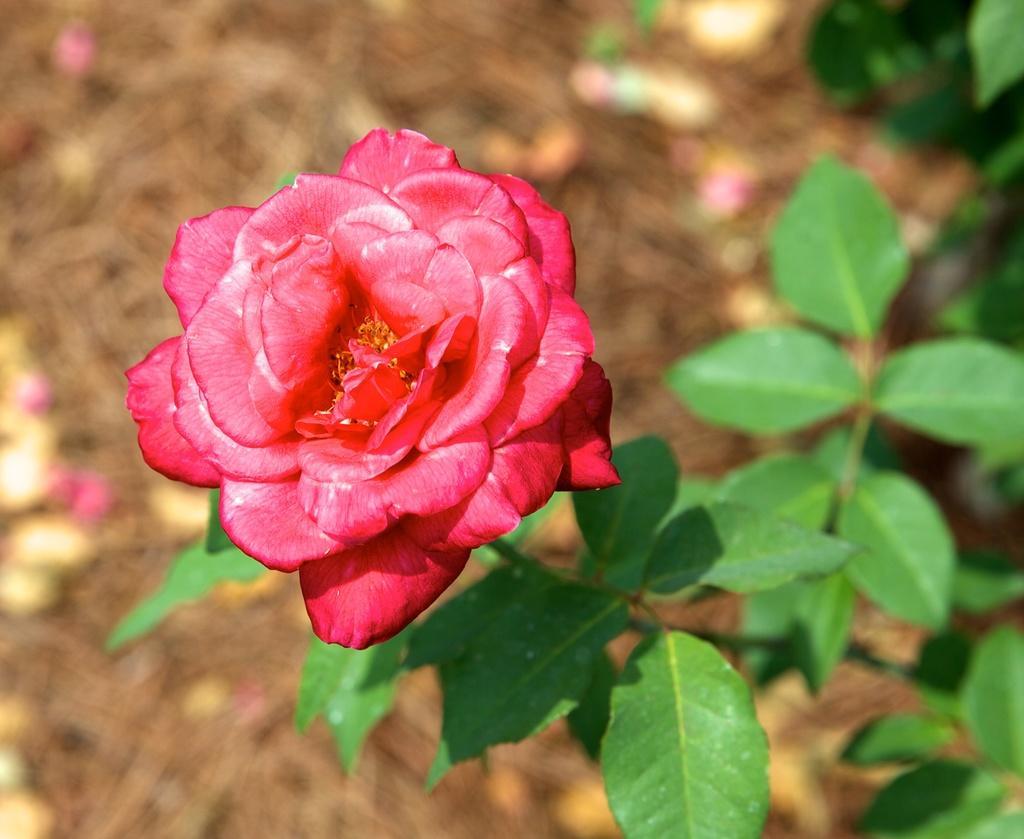Please provide a concise description of this image. In this image we can see one plant with red rose, some plants, some objects in the background and the background is blurred. 